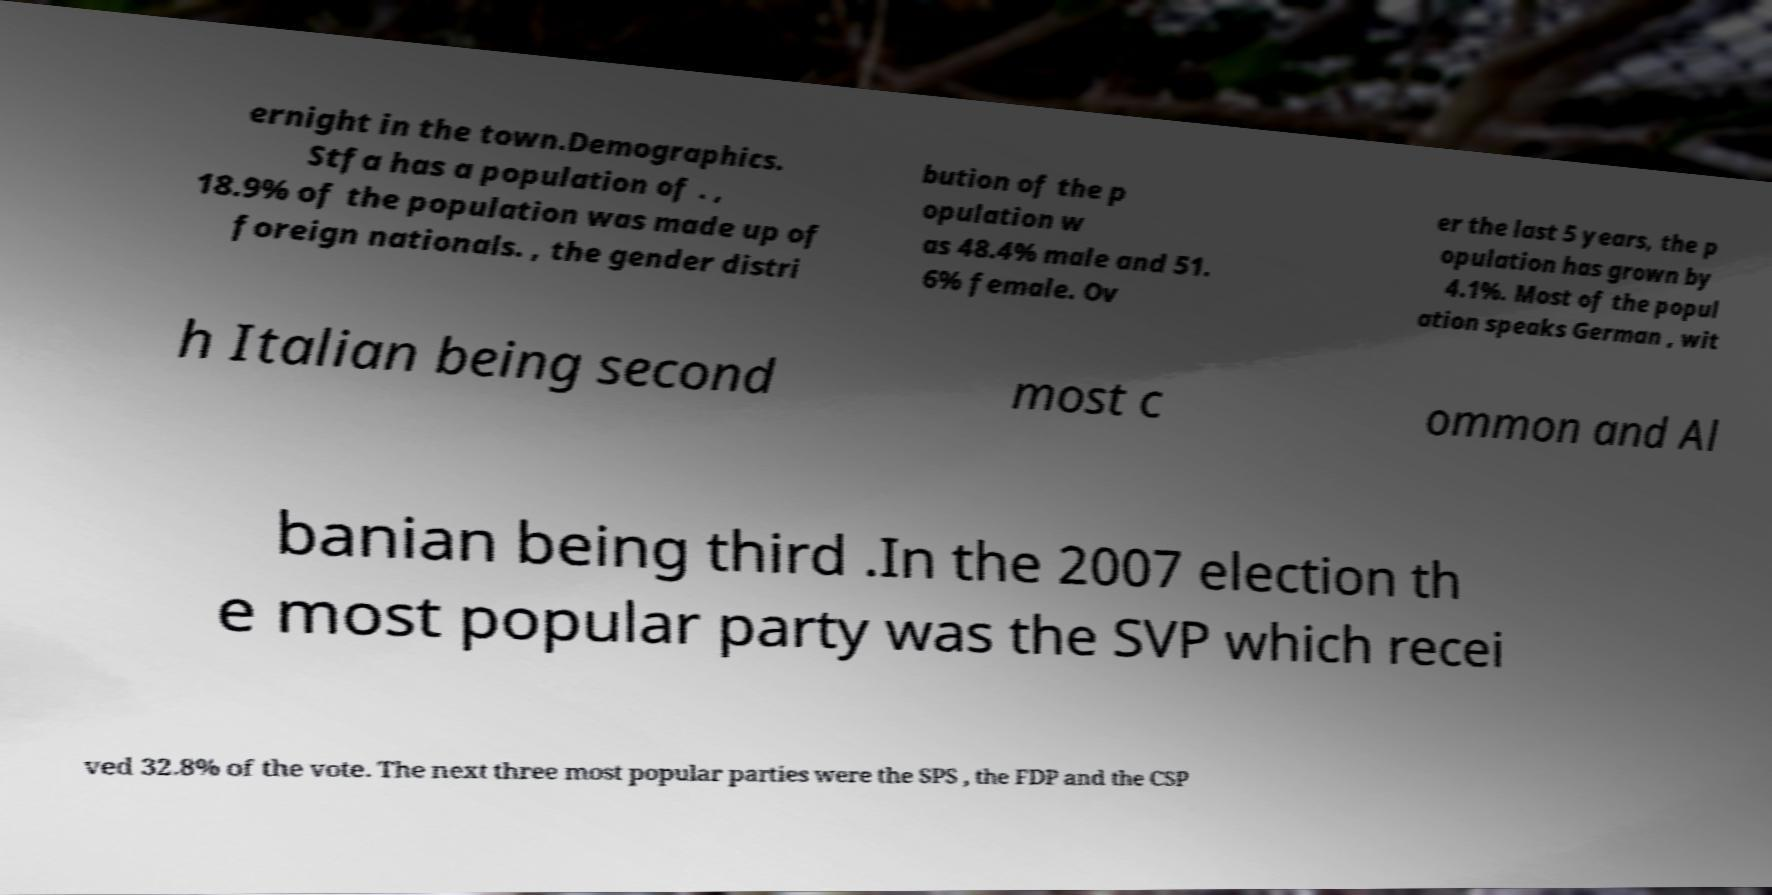I need the written content from this picture converted into text. Can you do that? ernight in the town.Demographics. Stfa has a population of . , 18.9% of the population was made up of foreign nationals. , the gender distri bution of the p opulation w as 48.4% male and 51. 6% female. Ov er the last 5 years, the p opulation has grown by 4.1%. Most of the popul ation speaks German , wit h Italian being second most c ommon and Al banian being third .In the 2007 election th e most popular party was the SVP which recei ved 32.8% of the vote. The next three most popular parties were the SPS , the FDP and the CSP 